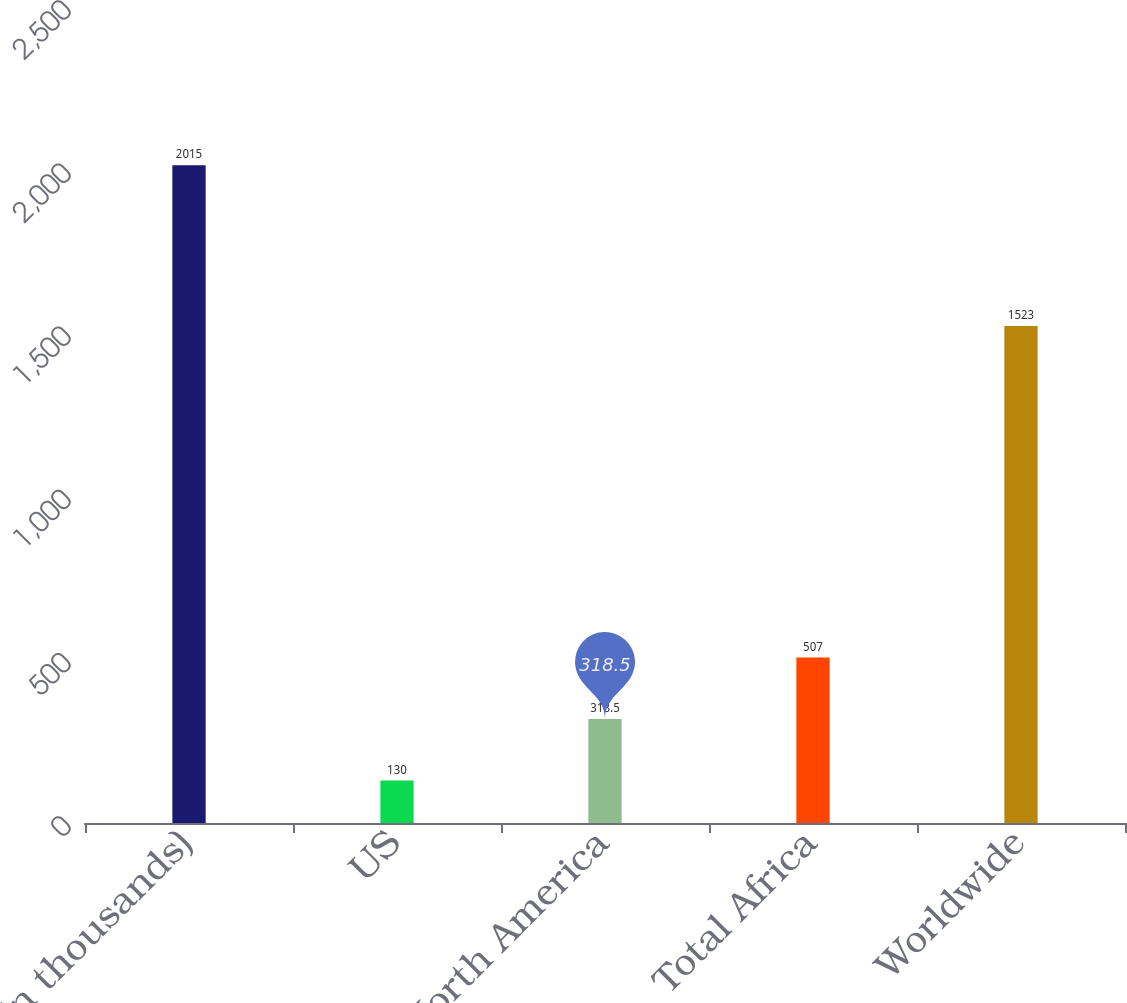Convert chart to OTSL. <chart><loc_0><loc_0><loc_500><loc_500><bar_chart><fcel>(In thousands)<fcel>US<fcel>Total North America<fcel>Total Africa<fcel>Worldwide<nl><fcel>2015<fcel>130<fcel>318.5<fcel>507<fcel>1523<nl></chart> 